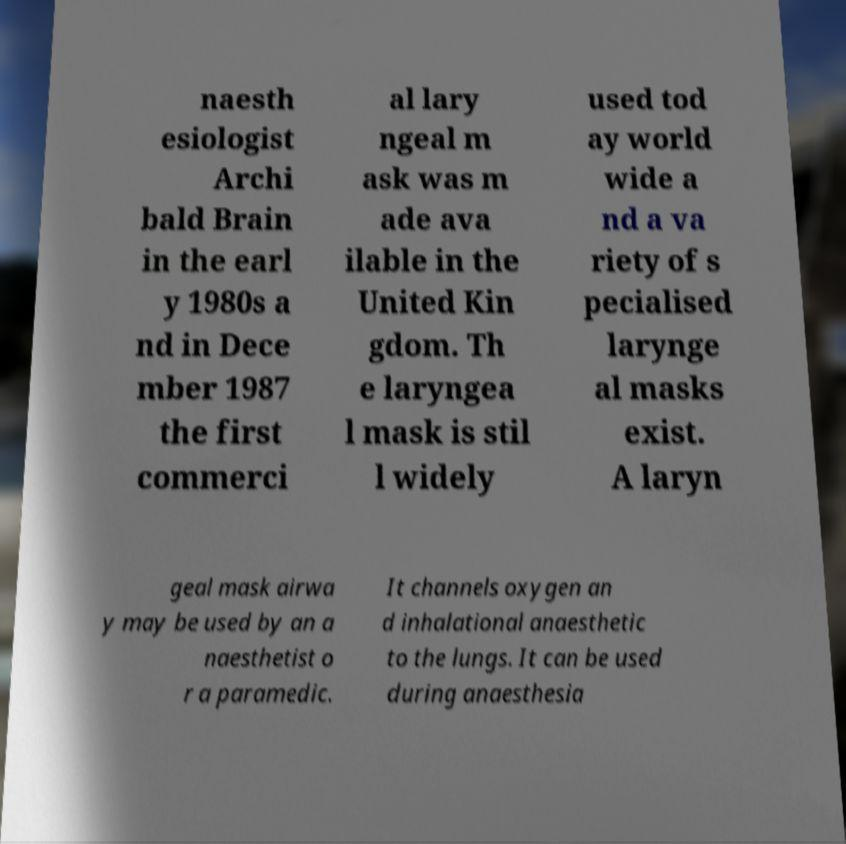Can you read and provide the text displayed in the image?This photo seems to have some interesting text. Can you extract and type it out for me? naesth esiologist Archi bald Brain in the earl y 1980s a nd in Dece mber 1987 the first commerci al lary ngeal m ask was m ade ava ilable in the United Kin gdom. Th e laryngea l mask is stil l widely used tod ay world wide a nd a va riety of s pecialised larynge al masks exist. A laryn geal mask airwa y may be used by an a naesthetist o r a paramedic. It channels oxygen an d inhalational anaesthetic to the lungs. It can be used during anaesthesia 